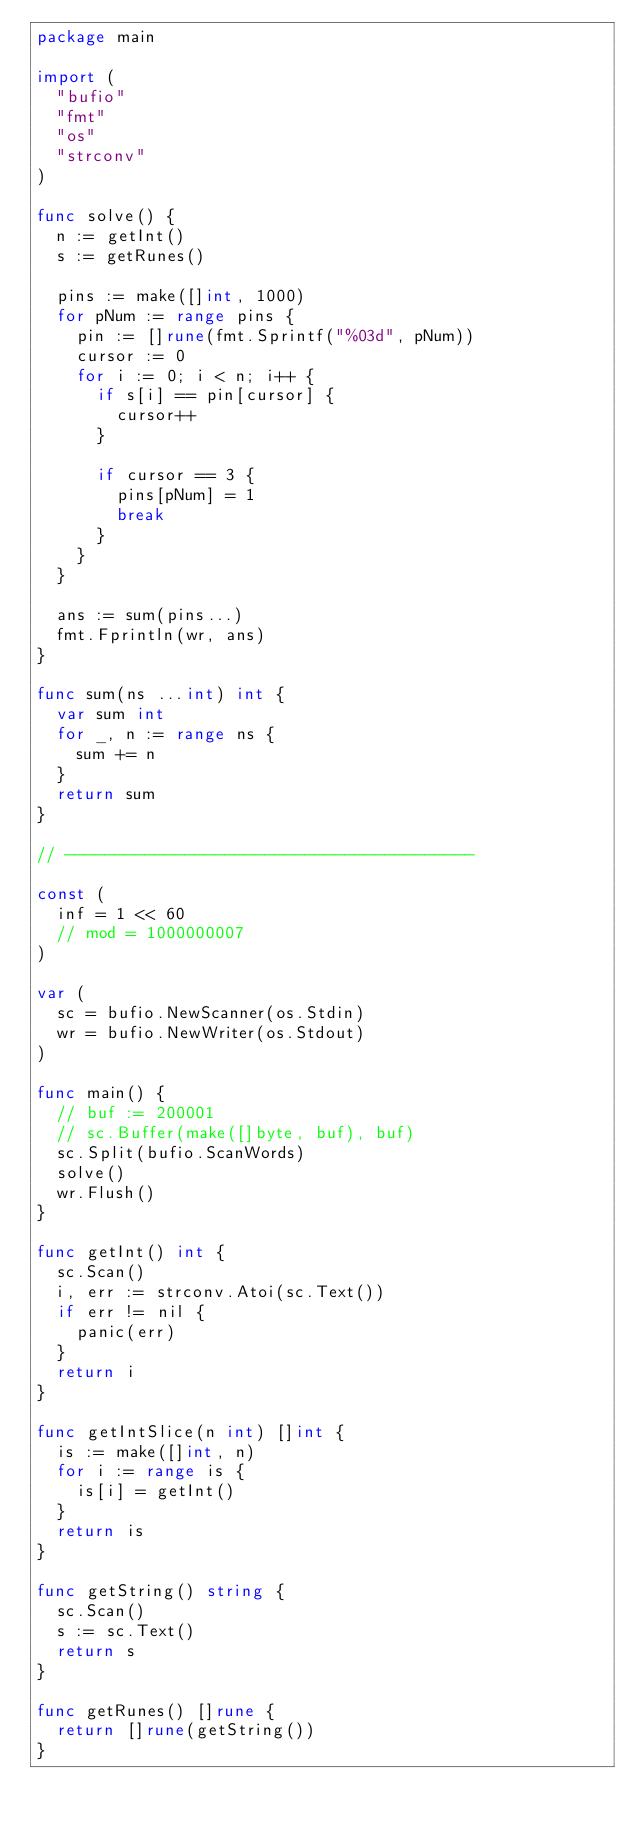<code> <loc_0><loc_0><loc_500><loc_500><_Go_>package main

import (
	"bufio"
	"fmt"
	"os"
	"strconv"
)

func solve() {
	n := getInt()
	s := getRunes()

	pins := make([]int, 1000)
	for pNum := range pins {
		pin := []rune(fmt.Sprintf("%03d", pNum))
		cursor := 0
		for i := 0; i < n; i++ {
			if s[i] == pin[cursor] {
				cursor++
			}

			if cursor == 3 {
				pins[pNum] = 1
				break
			}
		}
	}

	ans := sum(pins...)
	fmt.Fprintln(wr, ans)
}

func sum(ns ...int) int {
	var sum int
	for _, n := range ns {
		sum += n
	}
	return sum
}

// -----------------------------------------

const (
	inf = 1 << 60
	// mod = 1000000007
)

var (
	sc = bufio.NewScanner(os.Stdin)
	wr = bufio.NewWriter(os.Stdout)
)

func main() {
	// buf := 200001
	// sc.Buffer(make([]byte, buf), buf)
	sc.Split(bufio.ScanWords)
	solve()
	wr.Flush()
}

func getInt() int {
	sc.Scan()
	i, err := strconv.Atoi(sc.Text())
	if err != nil {
		panic(err)
	}
	return i
}

func getIntSlice(n int) []int {
	is := make([]int, n)
	for i := range is {
		is[i] = getInt()
	}
	return is
}

func getString() string {
	sc.Scan()
	s := sc.Text()
	return s
}

func getRunes() []rune {
	return []rune(getString())
}
</code> 